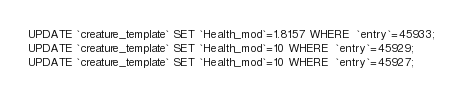<code> <loc_0><loc_0><loc_500><loc_500><_SQL_>UPDATE `creature_template` SET `Health_mod`=1.8157 WHERE  `entry`=45933;
UPDATE `creature_template` SET `Health_mod`=10 WHERE  `entry`=45929;
UPDATE `creature_template` SET `Health_mod`=10 WHERE  `entry`=45927;</code> 